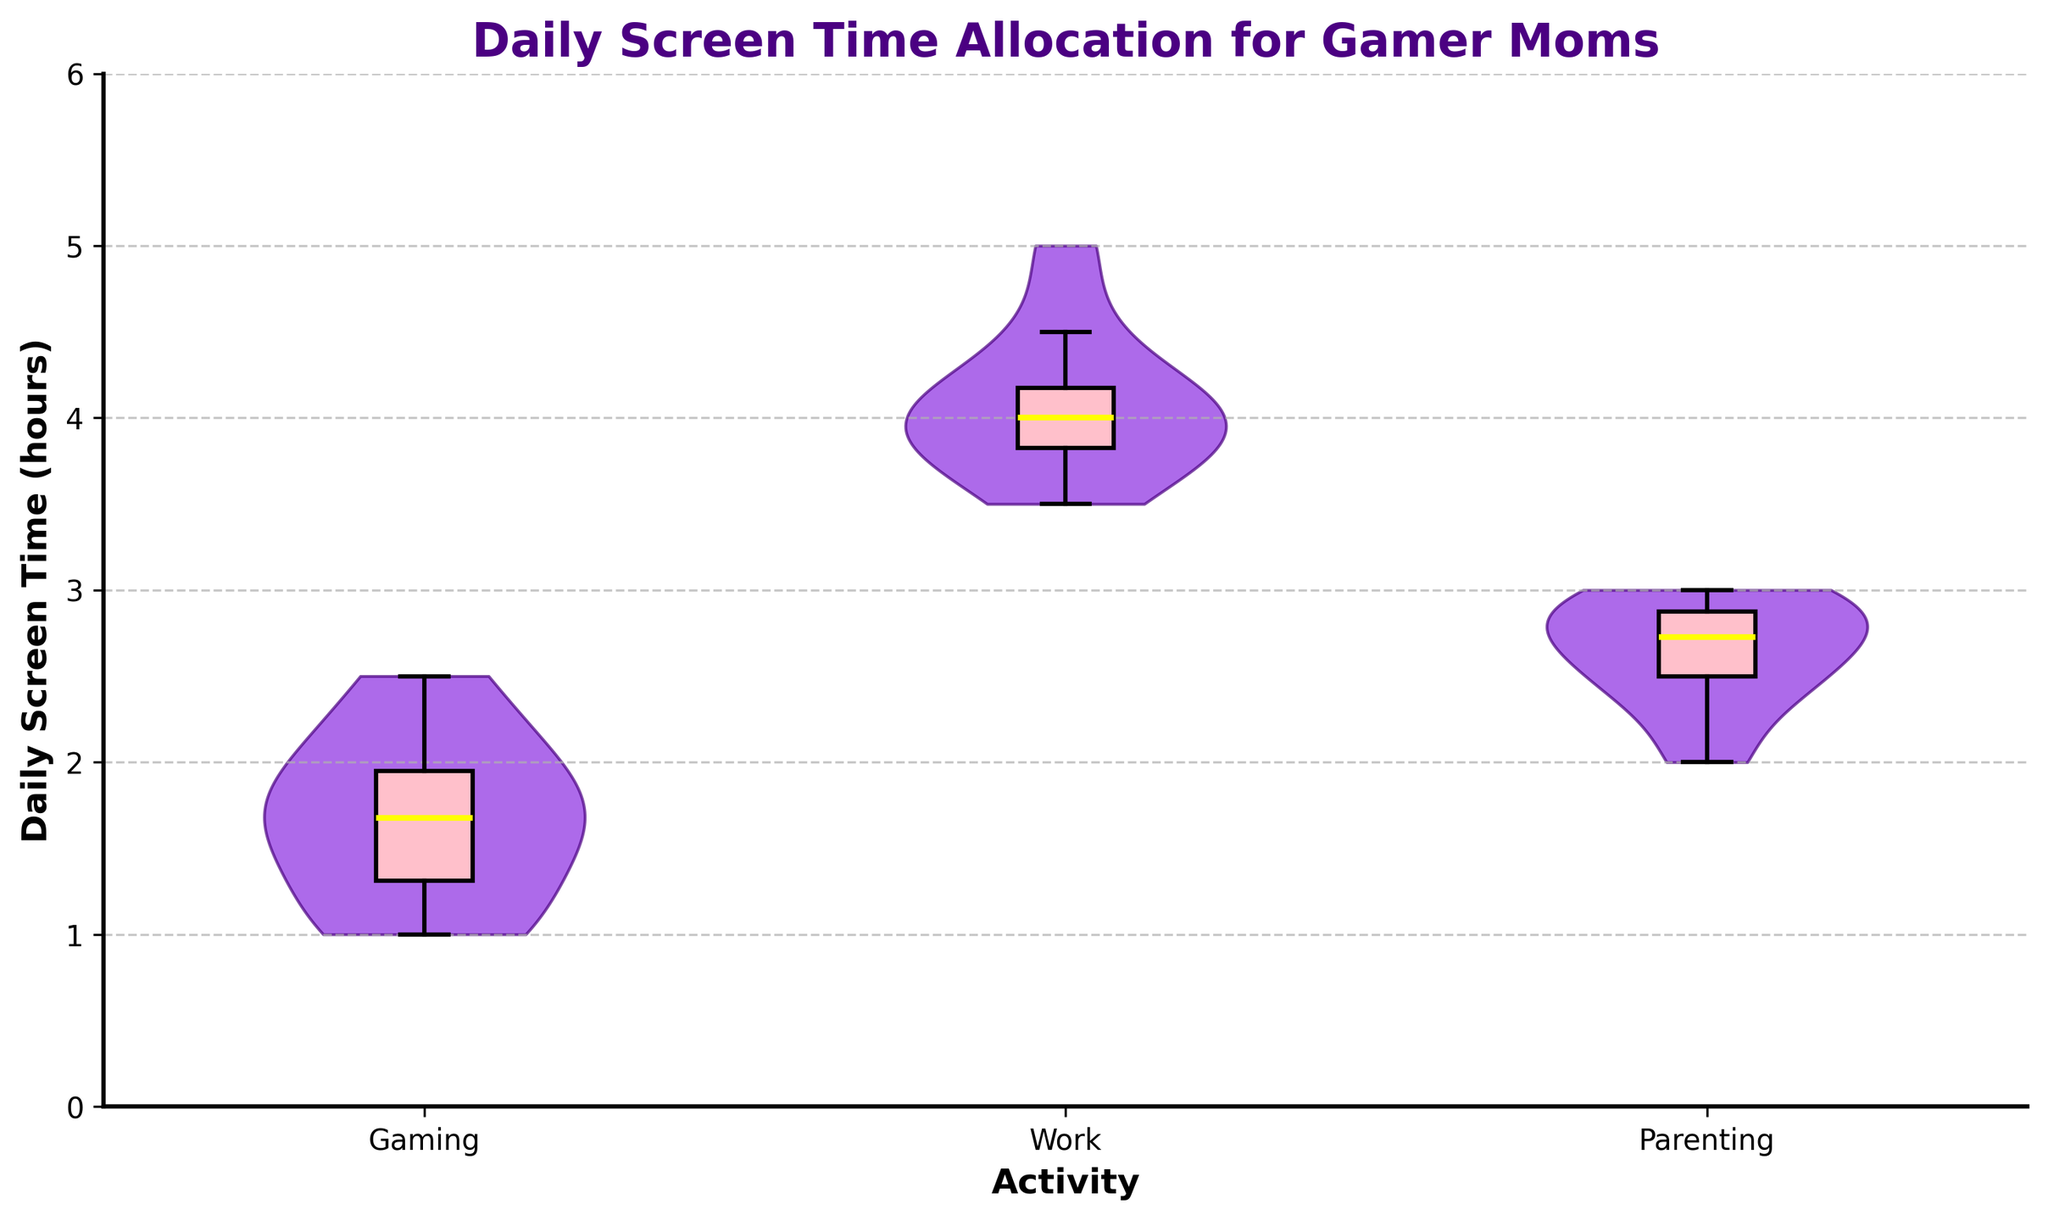What is the title of the figure? Read the title located at the top of the figure. The title is "Daily Screen Time Allocation for Gamer Moms".
Answer: Daily Screen Time Allocation for Gamer Moms What is the label on the y-axis? Read the label on the y-axis, which describes the measurement unit.
Answer: Daily Screen Time (hours) How many activities are compared in the figure? Count the number of distinct categories or labels on the x-axis. There are labels for "Gaming", "Work", and "Parenting".
Answer: 3 Which activity shows the highest median screen time? Observe the box plot overlays and identify which box plot has the median line at the highest position. The median for "Work" is the highest.
Answer: Work What is the median daily screen time for "Gaming"? Locate the median line in the box plot overlay for "Gaming" and read the value at its position. The median is around 1.75 hours.
Answer: 1.75 hours Which activity has the most variability in screen time? Look at the violin plots and observe which plot has the widest distribution, indicating higher variability. "Work" has the widest spread.
Answer: Work What is the interquartile range for "Parenting"? Identify the box plot for "Parenting" and calculate the interquartile range by finding the difference between the upper quartile (Q3) and the lower quartile (Q1). Q3 is around 2.9 and Q1 is around 2.5, so the IQR is 2.9 - 2.5.
Answer: 0.4 hours Between which activities is the screen time most similar? Compare the medians and the spread of the distributions in both the box plots and violin plots. "Gaming" and "Parenting" have more similar median and spread compared to "Work".
Answer: Gaming and Parenting Which activity has the smallest range of screen time? Examine the range of values in the distribution for each activity by observing the height of the violin plots. "Gaming" has the smallest range.
Answer: Gaming How does the median screen time for "Parenting" compare to the median screen time for "Gaming"? Compare the position of the median lines in the box plots for "Parenting" and "Gaming". The median for "Parenting" (around 2.75) is higher than the median for "Gaming" (around 1.75).
Answer: Higher 